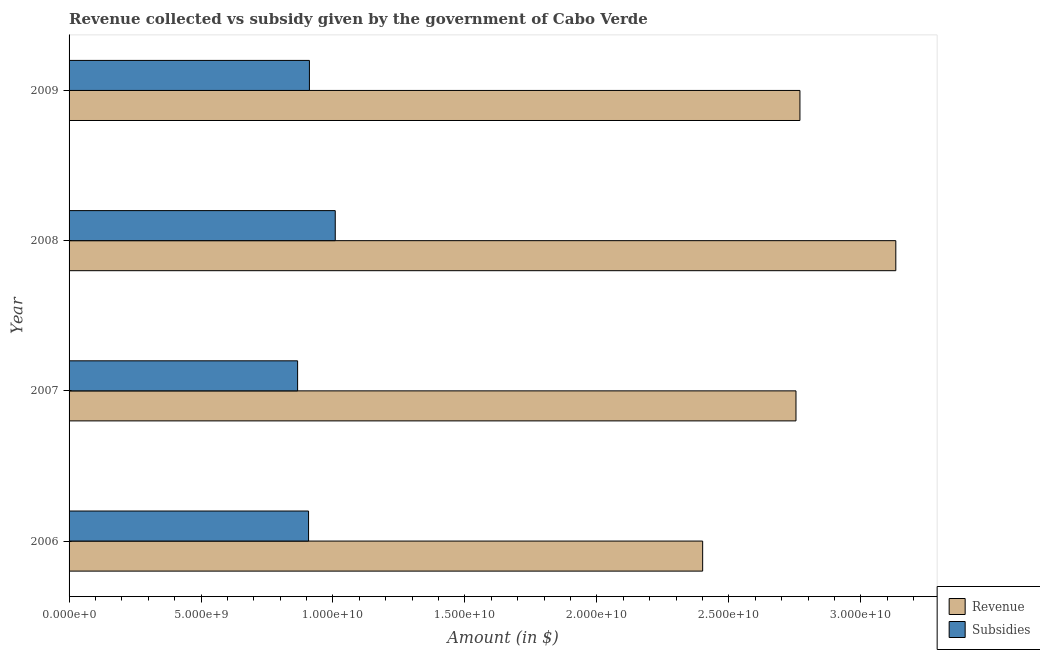How many groups of bars are there?
Your response must be concise. 4. Are the number of bars per tick equal to the number of legend labels?
Offer a very short reply. Yes. Are the number of bars on each tick of the Y-axis equal?
Your answer should be compact. Yes. How many bars are there on the 4th tick from the top?
Your response must be concise. 2. How many bars are there on the 4th tick from the bottom?
Provide a succinct answer. 2. In how many cases, is the number of bars for a given year not equal to the number of legend labels?
Provide a succinct answer. 0. What is the amount of revenue collected in 2007?
Offer a very short reply. 2.75e+1. Across all years, what is the maximum amount of revenue collected?
Keep it short and to the point. 3.13e+1. Across all years, what is the minimum amount of revenue collected?
Offer a very short reply. 2.40e+1. In which year was the amount of subsidies given maximum?
Provide a succinct answer. 2008. In which year was the amount of subsidies given minimum?
Ensure brevity in your answer.  2007. What is the total amount of subsidies given in the graph?
Make the answer very short. 3.69e+1. What is the difference between the amount of revenue collected in 2006 and that in 2009?
Keep it short and to the point. -3.69e+09. What is the difference between the amount of revenue collected in 2007 and the amount of subsidies given in 2006?
Provide a succinct answer. 1.85e+1. What is the average amount of revenue collected per year?
Provide a short and direct response. 2.76e+1. In the year 2009, what is the difference between the amount of revenue collected and amount of subsidies given?
Provide a succinct answer. 1.86e+1. In how many years, is the amount of subsidies given greater than 23000000000 $?
Keep it short and to the point. 0. What is the ratio of the amount of subsidies given in 2008 to that in 2009?
Offer a very short reply. 1.11. Is the amount of subsidies given in 2007 less than that in 2008?
Your answer should be very brief. Yes. Is the difference between the amount of subsidies given in 2008 and 2009 greater than the difference between the amount of revenue collected in 2008 and 2009?
Make the answer very short. No. What is the difference between the highest and the second highest amount of revenue collected?
Keep it short and to the point. 3.63e+09. What is the difference between the highest and the lowest amount of revenue collected?
Keep it short and to the point. 7.32e+09. In how many years, is the amount of subsidies given greater than the average amount of subsidies given taken over all years?
Offer a very short reply. 1. Is the sum of the amount of subsidies given in 2006 and 2009 greater than the maximum amount of revenue collected across all years?
Your answer should be compact. No. What does the 2nd bar from the top in 2008 represents?
Ensure brevity in your answer.  Revenue. What does the 1st bar from the bottom in 2009 represents?
Ensure brevity in your answer.  Revenue. How many bars are there?
Your response must be concise. 8. Are all the bars in the graph horizontal?
Make the answer very short. Yes. How many years are there in the graph?
Your answer should be compact. 4. Are the values on the major ticks of X-axis written in scientific E-notation?
Keep it short and to the point. Yes. Does the graph contain any zero values?
Ensure brevity in your answer.  No. How many legend labels are there?
Make the answer very short. 2. How are the legend labels stacked?
Your answer should be compact. Vertical. What is the title of the graph?
Your response must be concise. Revenue collected vs subsidy given by the government of Cabo Verde. What is the label or title of the X-axis?
Ensure brevity in your answer.  Amount (in $). What is the label or title of the Y-axis?
Offer a terse response. Year. What is the Amount (in $) in Revenue in 2006?
Offer a terse response. 2.40e+1. What is the Amount (in $) of Subsidies in 2006?
Ensure brevity in your answer.  9.07e+09. What is the Amount (in $) in Revenue in 2007?
Your response must be concise. 2.75e+1. What is the Amount (in $) of Subsidies in 2007?
Provide a succinct answer. 8.66e+09. What is the Amount (in $) of Revenue in 2008?
Offer a very short reply. 3.13e+1. What is the Amount (in $) in Subsidies in 2008?
Keep it short and to the point. 1.01e+1. What is the Amount (in $) of Revenue in 2009?
Give a very brief answer. 2.77e+1. What is the Amount (in $) of Subsidies in 2009?
Ensure brevity in your answer.  9.11e+09. Across all years, what is the maximum Amount (in $) of Revenue?
Your answer should be compact. 3.13e+1. Across all years, what is the maximum Amount (in $) of Subsidies?
Provide a short and direct response. 1.01e+1. Across all years, what is the minimum Amount (in $) of Revenue?
Ensure brevity in your answer.  2.40e+1. Across all years, what is the minimum Amount (in $) in Subsidies?
Your response must be concise. 8.66e+09. What is the total Amount (in $) of Revenue in the graph?
Offer a very short reply. 1.11e+11. What is the total Amount (in $) of Subsidies in the graph?
Your answer should be compact. 3.69e+1. What is the difference between the Amount (in $) in Revenue in 2006 and that in 2007?
Your answer should be very brief. -3.54e+09. What is the difference between the Amount (in $) of Subsidies in 2006 and that in 2007?
Offer a terse response. 4.15e+08. What is the difference between the Amount (in $) of Revenue in 2006 and that in 2008?
Make the answer very short. -7.32e+09. What is the difference between the Amount (in $) in Subsidies in 2006 and that in 2008?
Your answer should be compact. -1.01e+09. What is the difference between the Amount (in $) in Revenue in 2006 and that in 2009?
Your answer should be compact. -3.69e+09. What is the difference between the Amount (in $) of Subsidies in 2006 and that in 2009?
Your answer should be very brief. -3.27e+07. What is the difference between the Amount (in $) in Revenue in 2007 and that in 2008?
Make the answer very short. -3.78e+09. What is the difference between the Amount (in $) in Subsidies in 2007 and that in 2008?
Offer a terse response. -1.43e+09. What is the difference between the Amount (in $) of Revenue in 2007 and that in 2009?
Provide a short and direct response. -1.49e+08. What is the difference between the Amount (in $) of Subsidies in 2007 and that in 2009?
Offer a terse response. -4.48e+08. What is the difference between the Amount (in $) in Revenue in 2008 and that in 2009?
Your response must be concise. 3.63e+09. What is the difference between the Amount (in $) in Subsidies in 2008 and that in 2009?
Keep it short and to the point. 9.79e+08. What is the difference between the Amount (in $) in Revenue in 2006 and the Amount (in $) in Subsidies in 2007?
Your answer should be compact. 1.53e+1. What is the difference between the Amount (in $) in Revenue in 2006 and the Amount (in $) in Subsidies in 2008?
Your answer should be compact. 1.39e+1. What is the difference between the Amount (in $) in Revenue in 2006 and the Amount (in $) in Subsidies in 2009?
Offer a terse response. 1.49e+1. What is the difference between the Amount (in $) in Revenue in 2007 and the Amount (in $) in Subsidies in 2008?
Offer a terse response. 1.75e+1. What is the difference between the Amount (in $) of Revenue in 2007 and the Amount (in $) of Subsidies in 2009?
Your response must be concise. 1.84e+1. What is the difference between the Amount (in $) in Revenue in 2008 and the Amount (in $) in Subsidies in 2009?
Your response must be concise. 2.22e+1. What is the average Amount (in $) of Revenue per year?
Give a very brief answer. 2.76e+1. What is the average Amount (in $) of Subsidies per year?
Provide a succinct answer. 9.23e+09. In the year 2006, what is the difference between the Amount (in $) of Revenue and Amount (in $) of Subsidies?
Ensure brevity in your answer.  1.49e+1. In the year 2007, what is the difference between the Amount (in $) in Revenue and Amount (in $) in Subsidies?
Your answer should be compact. 1.89e+1. In the year 2008, what is the difference between the Amount (in $) of Revenue and Amount (in $) of Subsidies?
Offer a terse response. 2.12e+1. In the year 2009, what is the difference between the Amount (in $) of Revenue and Amount (in $) of Subsidies?
Keep it short and to the point. 1.86e+1. What is the ratio of the Amount (in $) in Revenue in 2006 to that in 2007?
Offer a very short reply. 0.87. What is the ratio of the Amount (in $) of Subsidies in 2006 to that in 2007?
Your answer should be compact. 1.05. What is the ratio of the Amount (in $) of Revenue in 2006 to that in 2008?
Offer a very short reply. 0.77. What is the ratio of the Amount (in $) of Subsidies in 2006 to that in 2008?
Ensure brevity in your answer.  0.9. What is the ratio of the Amount (in $) of Revenue in 2006 to that in 2009?
Your answer should be very brief. 0.87. What is the ratio of the Amount (in $) of Revenue in 2007 to that in 2008?
Make the answer very short. 0.88. What is the ratio of the Amount (in $) in Subsidies in 2007 to that in 2008?
Give a very brief answer. 0.86. What is the ratio of the Amount (in $) of Subsidies in 2007 to that in 2009?
Your answer should be compact. 0.95. What is the ratio of the Amount (in $) of Revenue in 2008 to that in 2009?
Keep it short and to the point. 1.13. What is the ratio of the Amount (in $) in Subsidies in 2008 to that in 2009?
Provide a short and direct response. 1.11. What is the difference between the highest and the second highest Amount (in $) in Revenue?
Make the answer very short. 3.63e+09. What is the difference between the highest and the second highest Amount (in $) in Subsidies?
Offer a terse response. 9.79e+08. What is the difference between the highest and the lowest Amount (in $) of Revenue?
Make the answer very short. 7.32e+09. What is the difference between the highest and the lowest Amount (in $) in Subsidies?
Give a very brief answer. 1.43e+09. 